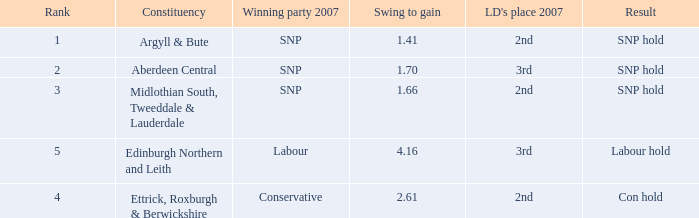How many times is the constituency edinburgh northern and leith? 1.0. 